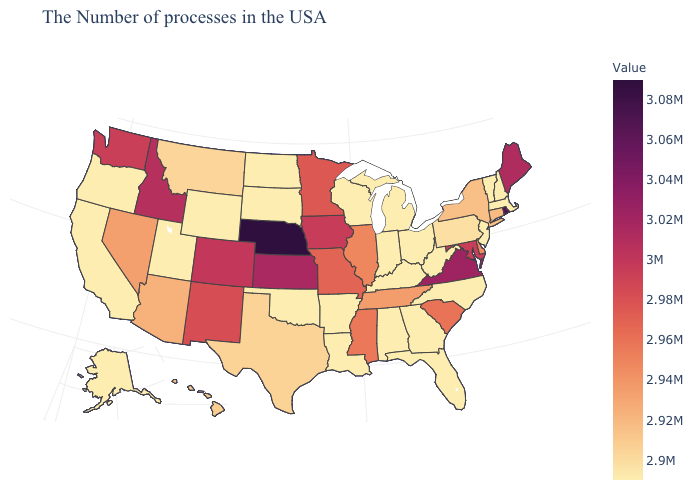Which states have the lowest value in the West?
Write a very short answer. Wyoming, Utah, California, Oregon, Alaska. Does the map have missing data?
Be succinct. No. Which states hav the highest value in the West?
Short answer required. Idaho. Which states have the lowest value in the South?
Concise answer only. North Carolina, West Virginia, Florida, Georgia, Kentucky, Alabama, Louisiana, Arkansas, Oklahoma. 